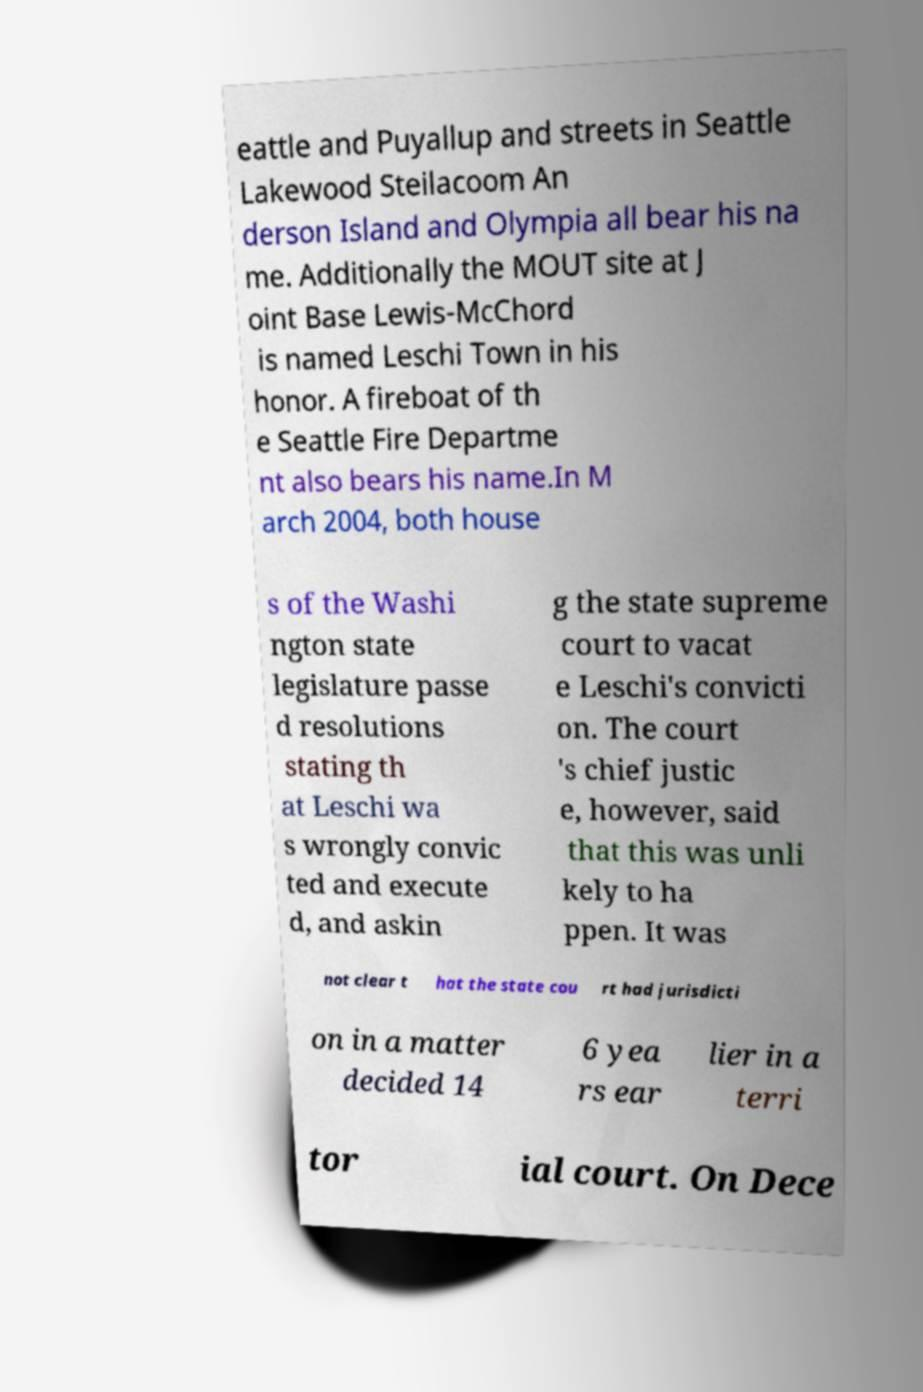There's text embedded in this image that I need extracted. Can you transcribe it verbatim? eattle and Puyallup and streets in Seattle Lakewood Steilacoom An derson Island and Olympia all bear his na me. Additionally the MOUT site at J oint Base Lewis-McChord is named Leschi Town in his honor. A fireboat of th e Seattle Fire Departme nt also bears his name.In M arch 2004, both house s of the Washi ngton state legislature passe d resolutions stating th at Leschi wa s wrongly convic ted and execute d, and askin g the state supreme court to vacat e Leschi's convicti on. The court 's chief justic e, however, said that this was unli kely to ha ppen. It was not clear t hat the state cou rt had jurisdicti on in a matter decided 14 6 yea rs ear lier in a terri tor ial court. On Dece 